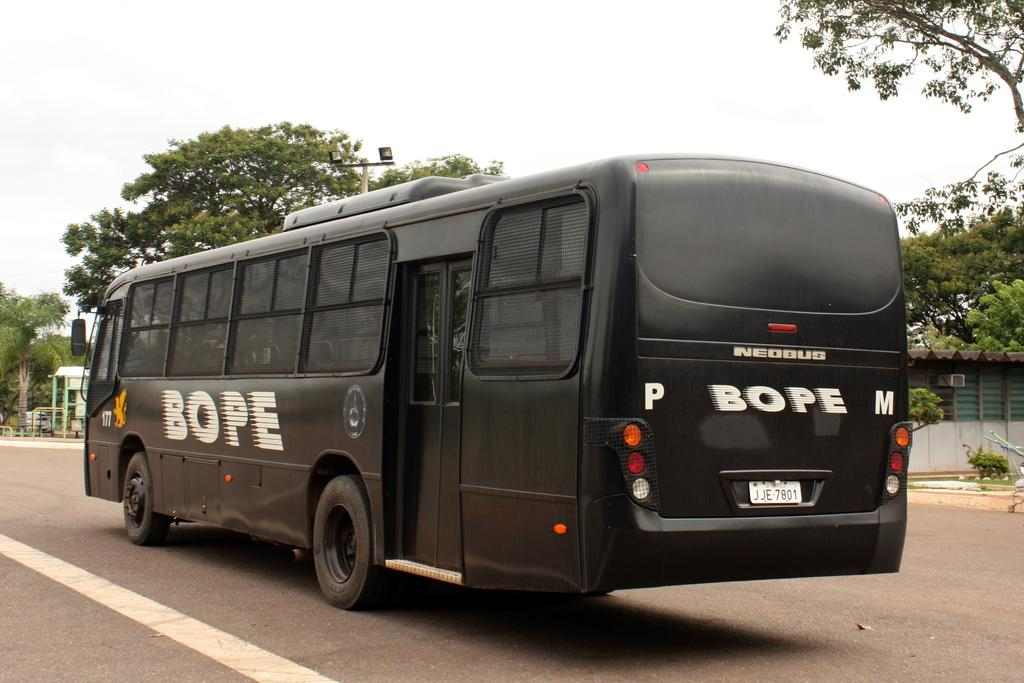What type of vehicle is in the image? There is a black color bus in the image. Where is the bus located? The bus is on the road. What can be seen in the background of the image? There are trees and the sky visible in the background of the image. How many friends are sitting on the bus in the image? There is no information about friends or passengers on the bus in the image. 